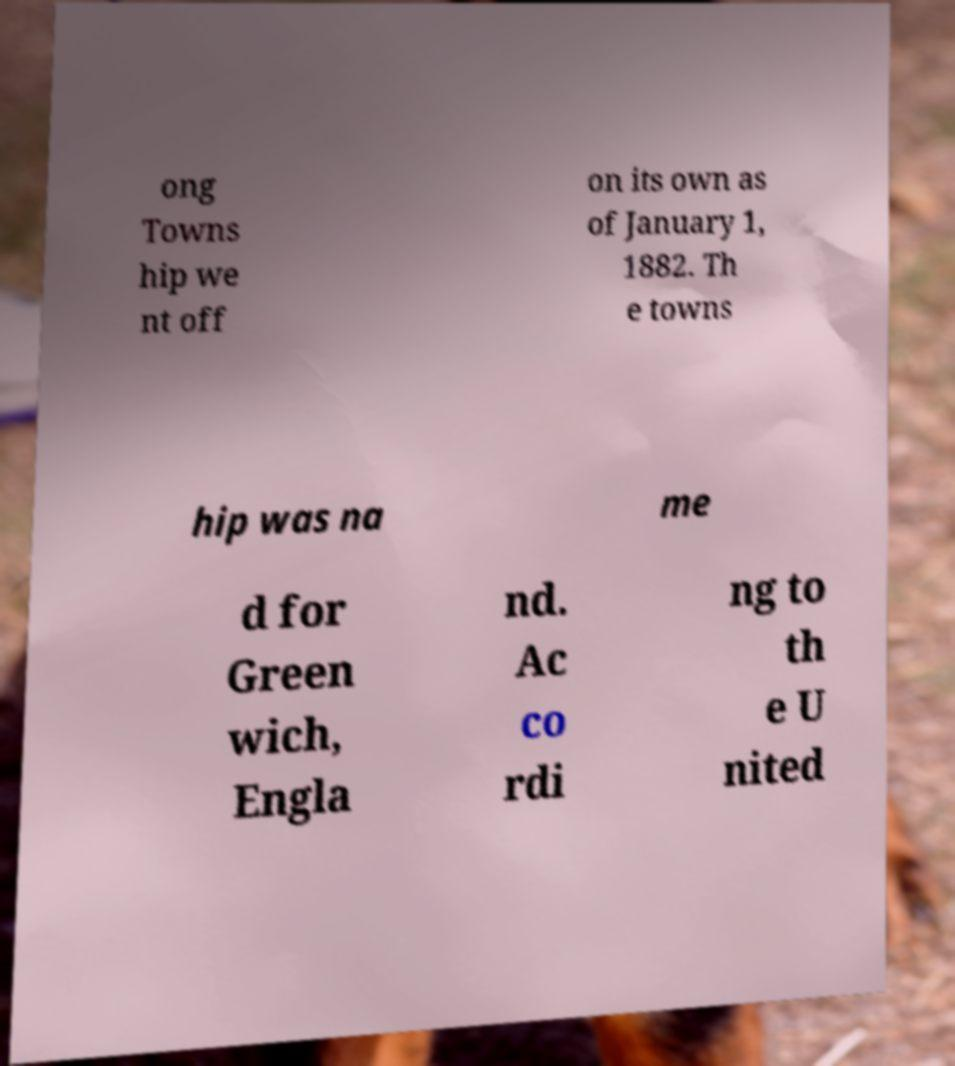I need the written content from this picture converted into text. Can you do that? ong Towns hip we nt off on its own as of January 1, 1882. Th e towns hip was na me d for Green wich, Engla nd. Ac co rdi ng to th e U nited 